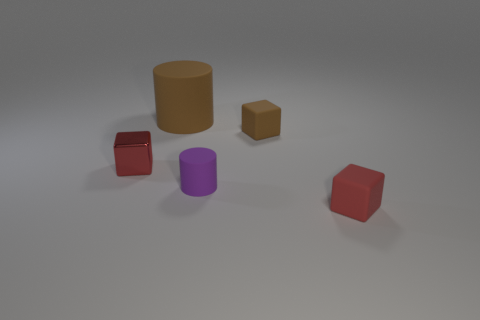The small rubber thing that is the same color as the big thing is what shape?
Offer a terse response. Cube. How many purple matte objects are the same shape as the big brown matte object?
Keep it short and to the point. 1. There is a brown rubber thing that is behind the brown thing in front of the brown cylinder; what size is it?
Offer a terse response. Large. How many gray objects are either matte cylinders or small matte cylinders?
Give a very brief answer. 0. Are there fewer tiny cylinders in front of the tiny cylinder than purple rubber cylinders that are left of the large rubber thing?
Your answer should be very brief. No. Is the size of the brown cylinder the same as the red cube that is in front of the small matte cylinder?
Your response must be concise. No. What number of purple matte cylinders have the same size as the purple object?
Your response must be concise. 0. What number of tiny things are either yellow rubber cylinders or purple cylinders?
Offer a terse response. 1. Is there a big object?
Offer a terse response. Yes. Are there more red things that are behind the small red matte thing than tiny rubber things in front of the small purple rubber thing?
Give a very brief answer. No. 